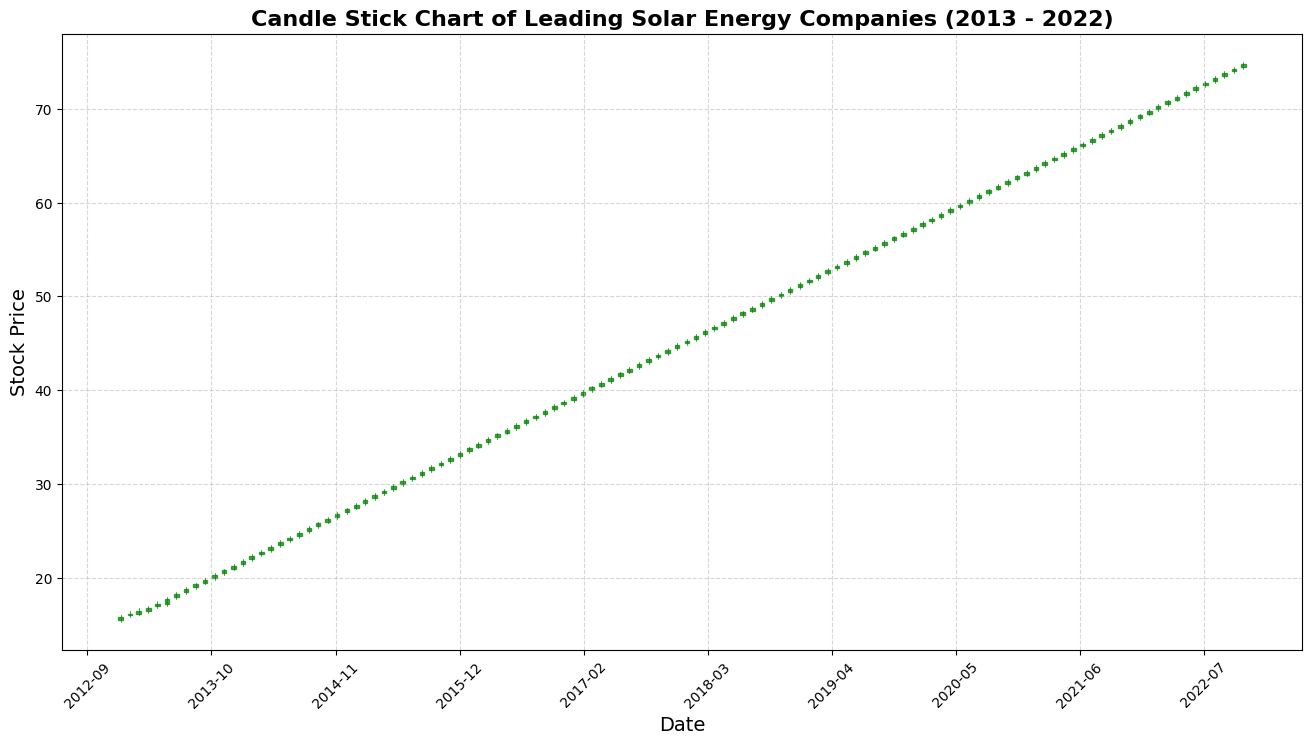What's the overall trend of the stock price from 2013 to 2022? To determine the overall trend, note that the stock price starts around $16 in 2013 and consistently rises to around $75 by the end of 2022. This indicates a steady upward trend over the decade.
Answer: Steady upward trend During which year did the stock price experience the most significant increase? To identify the year with the most significant increase, observe the gaps between the start and end prices for each year. In 2020, the stock price rises from approximately $57 to $62.80, marking a notable increase.
Answer: 2020 In which months do we observe the highest and lowest stock prices in the entire period? For the highest stock price, look for the peak values in the chart. The highest price is around $75 in December 2022. The lowest price is in January 2013, around $15.30.
Answer: Highest: December 2022, Lowest: January 2013 Which year had the least monthly fluctuations in stock prices? Least monthly fluctuations can be identified by observing candle figures with minimal differences between the opening and closing prices. The year 2014 shows candles with relatively smaller wicks and bodies, indicating less fluctuation.
Answer: 2014 What is the average closing stock price in 2019? First, note the closing prices for each month in 2019: 53.30, 53.80, 54.30, 54.80, 55.30, 55.80, 56.30, 56.80, 57.30, 57.80, 58.30, 58.80. The sum is 666.20. Divide this by 12 to get the average: 666.20/12.
Answer: $55.52 Compare the stock prices at the start and end of 2015. Did it increase or decrease? At the start of 2015 (January), the closing price is around $27.30. At the end of 2015 (December), the closing price is about $32.80. This shows an increase.
Answer: Increase Did the volume of traded stocks show an increasing or decreasing trend from 2013 to 2022? To determine this, observe if there's an upward or downward trajectory in the volume figures over the years. The volume starts at 1,204,000 in January 2013 and increases to 7,000,000 by December 2022.
Answer: Increasing trend Compare the stock prices in January 2013 and January 2021. Which month closed higher? In January 2013, the closing price is around $15.80. In January 2021, it is around $63.30. January 2021 closed higher.
Answer: January 2021 Which month and year experienced a drop in closing prices compares to its previous month and year? Identify the months where the closing price is lower than the previous month's closing price. For example, in October 2021, the closing price is lower than September 2021.
Answer: October 2021 What was the maximum closing stock price in the first half of 2017? Review the monthly closing prices for the first half of 2017 (January to June). The highest closing price is $41.80 in June 2017.
Answer: $41.80 